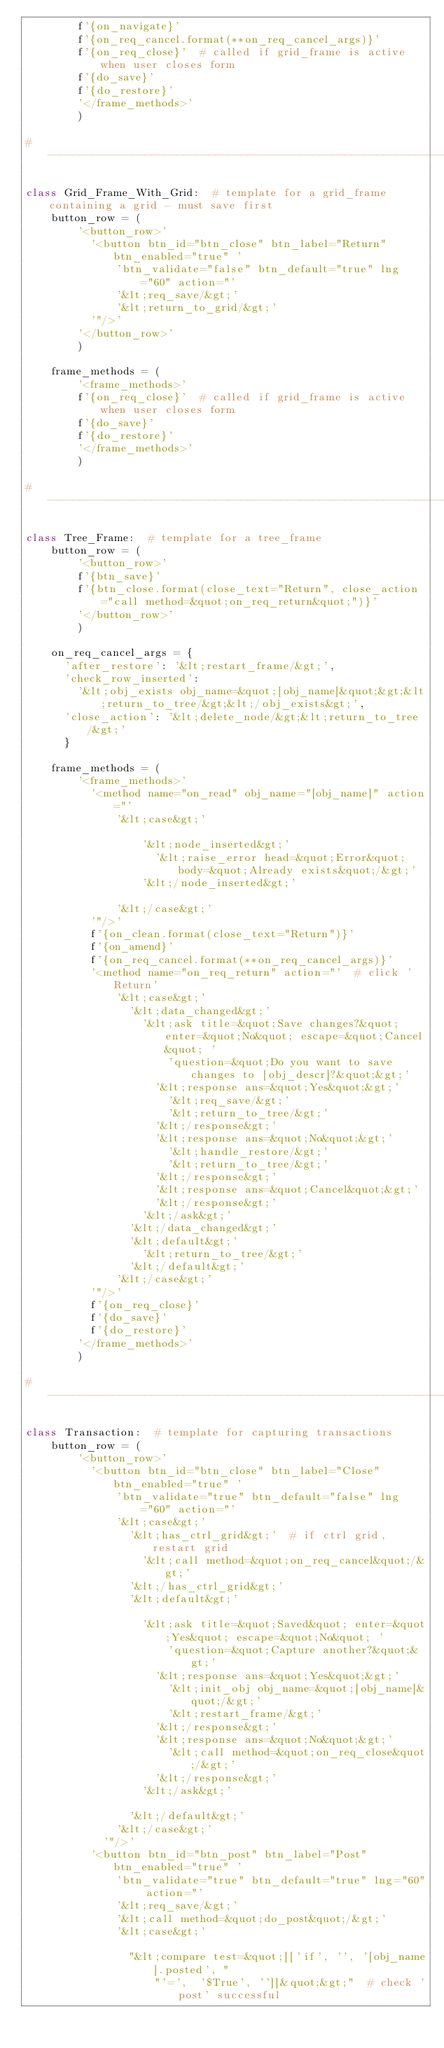Convert code to text. <code><loc_0><loc_0><loc_500><loc_500><_Python_>        f'{on_navigate}'
        f'{on_req_cancel.format(**on_req_cancel_args)}'
        f'{on_req_close}'  # called if grid_frame is active when user closes form
        f'{do_save}'
        f'{do_restore}'
        '</frame_methods>'
        )

#----------------------------------------------------------------------------

class Grid_Frame_With_Grid:  # template for a grid_frame containing a grid - must save first
    button_row = (
        '<button_row>'
          '<button btn_id="btn_close" btn_label="Return" btn_enabled="true" '
              'btn_validate="false" btn_default="true" lng="60" action="'
              '&lt;req_save/&gt;'
              '&lt;return_to_grid/&gt;'
          '"/>'
        '</button_row>'
        )

    frame_methods = (
        '<frame_methods>'
        f'{on_req_close}'  # called if grid_frame is active when user closes form
        f'{do_save}'
        f'{do_restore}'
        '</frame_methods>'
        )

#----------------------------------------------------------------------------

class Tree_Frame:  # template for a tree_frame
    button_row = (
        '<button_row>'
        f'{btn_save}'
        f'{btn_close.format(close_text="Return", close_action="call method=&quot;on_req_return&quot;")}'
        '</button_row>'
        )

    on_req_cancel_args = {
      'after_restore': '&lt;restart_frame/&gt;',
      'check_row_inserted':
        '&lt;obj_exists obj_name=&quot;[obj_name]&quot;&gt;&lt;return_to_tree/&gt;&lt;/obj_exists&gt;',
      'close_action': '&lt;delete_node/&gt;&lt;return_to_tree/&gt;'
      }

    frame_methods = (
        '<frame_methods>'
          '<method name="on_read" obj_name="[obj_name]" action="'
              '&lt;case&gt;'

                  '&lt;node_inserted&gt;'
                    '&lt;raise_error head=&quot;Error&quot; body=&quot;Already exists&quot;/&gt;'
                  '&lt;/node_inserted&gt;'

              '&lt;/case&gt;'
          '"/>'
          f'{on_clean.format(close_text="Return")}'
          f'{on_amend}'
          f'{on_req_cancel.format(**on_req_cancel_args)}'
          '<method name="on_req_return" action="'  # click 'Return'
              '&lt;case&gt;'
                '&lt;data_changed&gt;'
                  '&lt;ask title=&quot;Save changes?&quot; enter=&quot;No&quot; escape=&quot;Cancel&quot; '
                      'question=&quot;Do you want to save changes to [obj_descr]?&quot;&gt;'
                    '&lt;response ans=&quot;Yes&quot;&gt;'
                      '&lt;req_save/&gt;'
                      '&lt;return_to_tree/&gt;'
                    '&lt;/response&gt;'
                    '&lt;response ans=&quot;No&quot;&gt;'
                      '&lt;handle_restore/&gt;'
                      '&lt;return_to_tree/&gt;'
                    '&lt;/response&gt;'
                    '&lt;response ans=&quot;Cancel&quot;&gt;'
                    '&lt;/response&gt;'
                  '&lt;/ask&gt;'
                '&lt;/data_changed&gt;'
                '&lt;default&gt;'
                  '&lt;return_to_tree/&gt;'
                '&lt;/default&gt;'
              '&lt;/case&gt;'
          '"/>'
          f'{on_req_close}'
          f'{do_save}'
          f'{do_restore}'
        '</frame_methods>'
        )

#----------------------------------------------------------------------------

class Transaction:  # template for capturing transactions
    button_row = (
        '<button_row>'
          '<button btn_id="btn_close" btn_label="Close" btn_enabled="true" '
              'btn_validate="true" btn_default="false" lng="60" action="'
              '&lt;case&gt;'
                '&lt;has_ctrl_grid&gt;'  # if ctrl grid, restart grid
                  '&lt;call method=&quot;on_req_cancel&quot;/&gt;'
                '&lt;/has_ctrl_grid&gt;'
                '&lt;default&gt;'

                  '&lt;ask title=&quot;Saved&quot; enter=&quot;Yes&quot; escape=&quot;No&quot; '
                      'question=&quot;Capture another?&quot;&gt;'
                    '&lt;response ans=&quot;Yes&quot;&gt;'
                      '&lt;init_obj obj_name=&quot;[obj_name]&quot;/&gt;'
                      '&lt;restart_frame/&gt;'
                    '&lt;/response&gt;'
                    '&lt;response ans=&quot;No&quot;&gt;'
                      '&lt;call method=&quot;on_req_close&quot;/&gt;'
                    '&lt;/response&gt;'
                  '&lt;/ask&gt;'

                '&lt;/default&gt;'
              '&lt;/case&gt;'
            '"/>'
          '<button btn_id="btn_post" btn_label="Post" btn_enabled="true" '
              'btn_validate="true" btn_default="true" lng="60" action="'
              '&lt;req_save/&gt;'
              '&lt;call method=&quot;do_post&quot;/&gt;'
              '&lt;case&gt;'

                "&lt;compare test=&quot;[['if', '', '[obj_name].posted', "
                    "'=',  '$True', '']]&quot;&gt;"  # check 'post' successful
</code> 